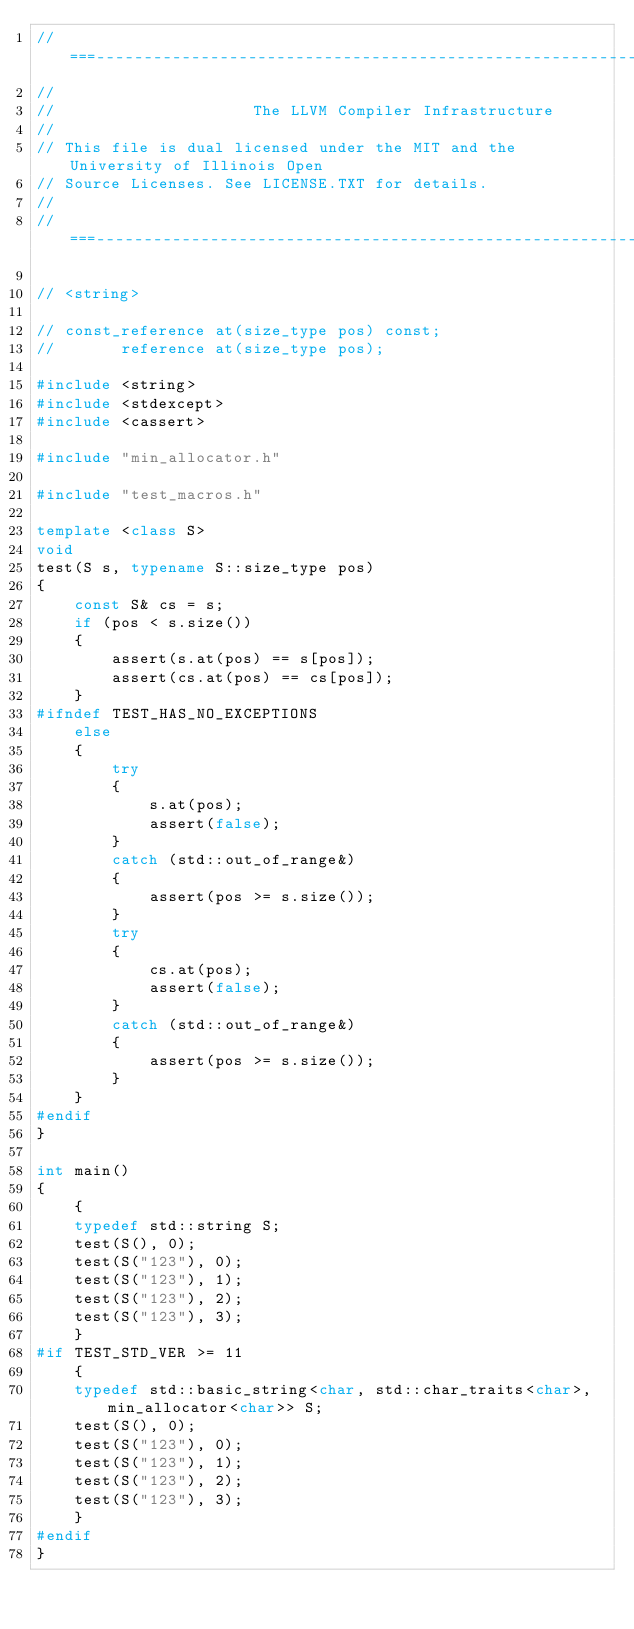Convert code to text. <code><loc_0><loc_0><loc_500><loc_500><_C++_>//===----------------------------------------------------------------------===//
//
//                     The LLVM Compiler Infrastructure
//
// This file is dual licensed under the MIT and the University of Illinois Open
// Source Licenses. See LICENSE.TXT for details.
//
//===----------------------------------------------------------------------===//

// <string>

// const_reference at(size_type pos) const;
//       reference at(size_type pos);

#include <string>
#include <stdexcept>
#include <cassert>

#include "min_allocator.h"

#include "test_macros.h"

template <class S>
void
test(S s, typename S::size_type pos)
{
    const S& cs = s;
    if (pos < s.size())
    {
        assert(s.at(pos) == s[pos]);
        assert(cs.at(pos) == cs[pos]);
    }
#ifndef TEST_HAS_NO_EXCEPTIONS
    else
    {
        try
        {
            s.at(pos);
            assert(false);
        }
        catch (std::out_of_range&)
        {
            assert(pos >= s.size());
        }
        try
        {
            cs.at(pos);
            assert(false);
        }
        catch (std::out_of_range&)
        {
            assert(pos >= s.size());
        }
    }
#endif
}

int main()
{
    {
    typedef std::string S;
    test(S(), 0);
    test(S("123"), 0);
    test(S("123"), 1);
    test(S("123"), 2);
    test(S("123"), 3);
    }
#if TEST_STD_VER >= 11
    {
    typedef std::basic_string<char, std::char_traits<char>, min_allocator<char>> S;
    test(S(), 0);
    test(S("123"), 0);
    test(S("123"), 1);
    test(S("123"), 2);
    test(S("123"), 3);
    }
#endif
}
</code> 